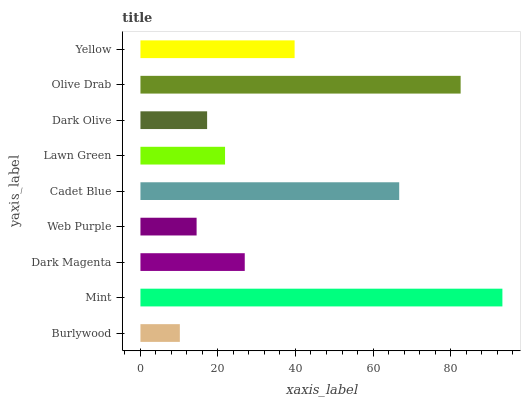Is Burlywood the minimum?
Answer yes or no. Yes. Is Mint the maximum?
Answer yes or no. Yes. Is Dark Magenta the minimum?
Answer yes or no. No. Is Dark Magenta the maximum?
Answer yes or no. No. Is Mint greater than Dark Magenta?
Answer yes or no. Yes. Is Dark Magenta less than Mint?
Answer yes or no. Yes. Is Dark Magenta greater than Mint?
Answer yes or no. No. Is Mint less than Dark Magenta?
Answer yes or no. No. Is Dark Magenta the high median?
Answer yes or no. Yes. Is Dark Magenta the low median?
Answer yes or no. Yes. Is Burlywood the high median?
Answer yes or no. No. Is Olive Drab the low median?
Answer yes or no. No. 